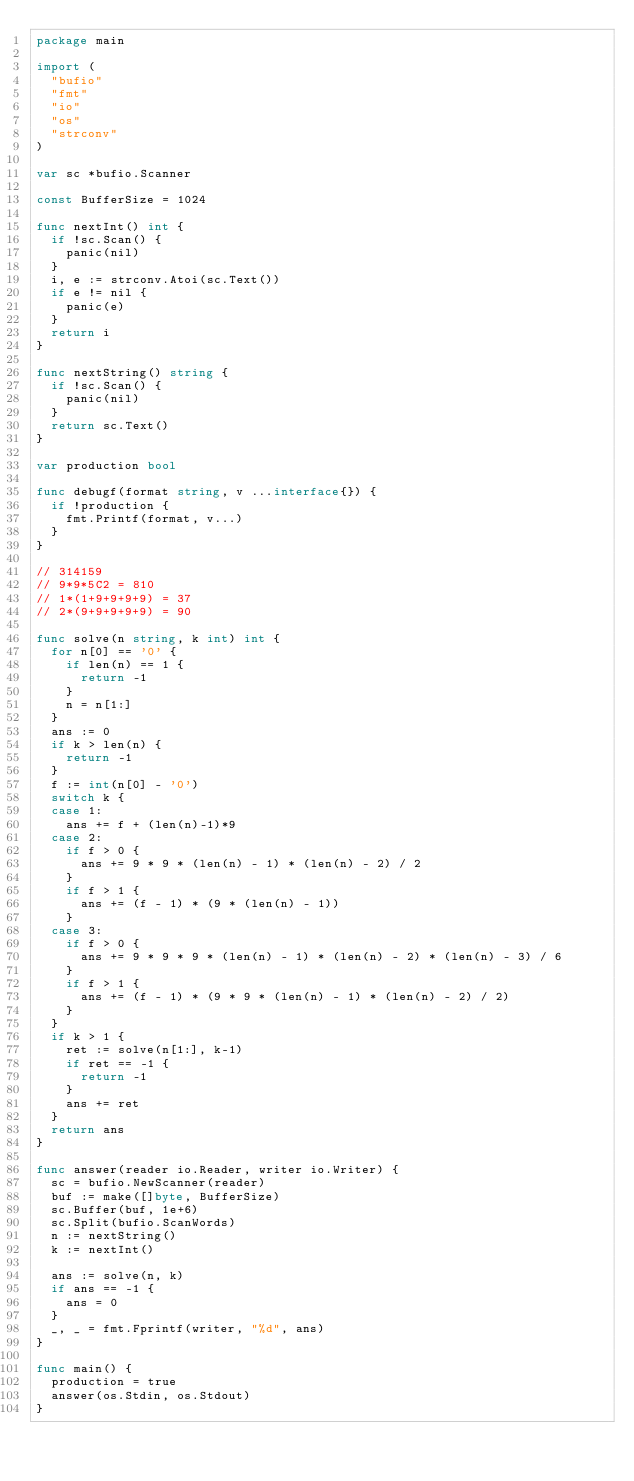<code> <loc_0><loc_0><loc_500><loc_500><_Go_>package main

import (
	"bufio"
	"fmt"
	"io"
	"os"
	"strconv"
)

var sc *bufio.Scanner

const BufferSize = 1024

func nextInt() int {
	if !sc.Scan() {
		panic(nil)
	}
	i, e := strconv.Atoi(sc.Text())
	if e != nil {
		panic(e)
	}
	return i
}

func nextString() string {
	if !sc.Scan() {
		panic(nil)
	}
	return sc.Text()
}

var production bool

func debugf(format string, v ...interface{}) {
	if !production {
		fmt.Printf(format, v...)
	}
}

// 314159
// 9*9*5C2 = 810
// 1*(1+9+9+9+9) = 37
// 2*(9+9+9+9+9) = 90

func solve(n string, k int) int {
	for n[0] == '0' {
		if len(n) == 1 {
			return -1
		}
		n = n[1:]
	}
	ans := 0
	if k > len(n) {
		return -1
	}
	f := int(n[0] - '0')
	switch k {
	case 1:
		ans += f + (len(n)-1)*9
	case 2:
		if f > 0 {
			ans += 9 * 9 * (len(n) - 1) * (len(n) - 2) / 2
		}
		if f > 1 {
			ans += (f - 1) * (9 * (len(n) - 1))
		}
	case 3:
		if f > 0 {
			ans += 9 * 9 * 9 * (len(n) - 1) * (len(n) - 2) * (len(n) - 3) / 6
		}
		if f > 1 {
			ans += (f - 1) * (9 * 9 * (len(n) - 1) * (len(n) - 2) / 2)
		}
	}
	if k > 1 {
		ret := solve(n[1:], k-1)
		if ret == -1 {
			return -1
		}
		ans += ret
	}
	return ans
}

func answer(reader io.Reader, writer io.Writer) {
	sc = bufio.NewScanner(reader)
	buf := make([]byte, BufferSize)
	sc.Buffer(buf, 1e+6)
	sc.Split(bufio.ScanWords)
	n := nextString()
	k := nextInt()

	ans := solve(n, k)
	if ans == -1 {
		ans = 0
	}
	_, _ = fmt.Fprintf(writer, "%d", ans)
}

func main() {
	production = true
	answer(os.Stdin, os.Stdout)
}
</code> 